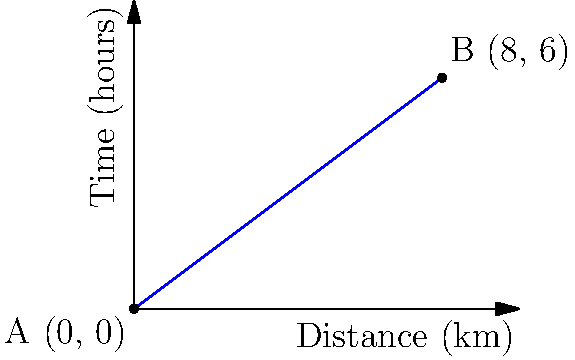As a tour guide for river cruises in the Sundarbans, you're planning a new route from point A to point B. The graph shows the relationship between distance traveled and time taken. Using the point-slope form, what equation describes this linear route if the cruise starts at point A (0, 0) and ends at point B (8, 6)? To find the equation of the line in point-slope form, we need to follow these steps:

1) The point-slope form of a line is $y - y_1 = m(x - x_1)$, where $(x_1, y_1)$ is a point on the line and $m$ is the slope.

2) We're given two points: A(0, 0) and B(8, 6). Let's use A(0, 0) as our $(x_1, y_1)$.

3) Calculate the slope $m$ using the formula:
   $m = \frac{y_2 - y_1}{x_2 - x_1} = \frac{6 - 0}{8 - 0} = \frac{6}{8} = \frac{3}{4}$

4) Now we can substitute these values into the point-slope form:
   $y - 0 = \frac{3}{4}(x - 0)$

5) Simplify:
   $y = \frac{3}{4}x$

This equation represents the linear route of the river cruise, where $y$ is the time in hours and $x$ is the distance traveled in kilometers.
Answer: $y = \frac{3}{4}x$ 